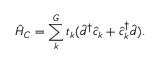Convert formula to latex. <formula><loc_0><loc_0><loc_500><loc_500>\hat { H } _ { C } = \sum _ { k } ^ { G } t _ { k } ( \hat { d } ^ { \dagger } \hat { c } _ { k } + \hat { c } _ { k } ^ { \dagger } \hat { d } ) .</formula> 